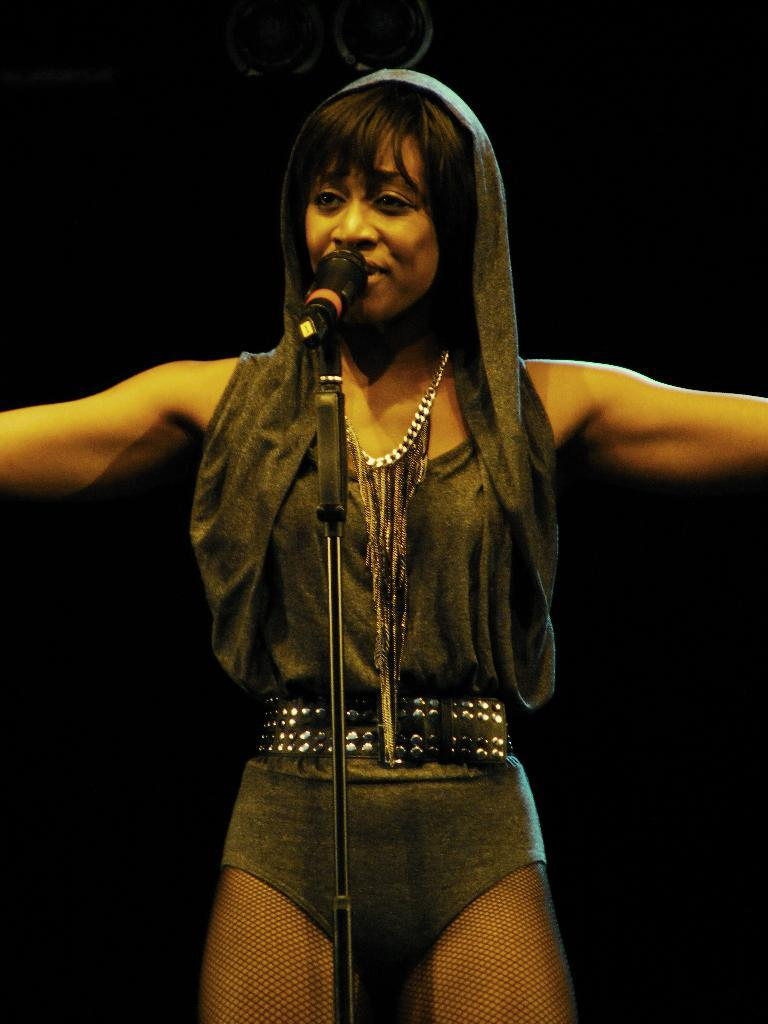Who is the main subject in the foreground of the image? There is a woman in the foreground of the image. What is the woman doing in front of the mic? The woman is standing in front of a mic. What is the woman's body language in the image? The woman is stretching both her hands. What is the color of the background in the image? The background of the image is dark. What type of sink is visible in the image? There is no sink present in the image. What musical instrument is the woman playing in the image? The woman is not playing any musical instrument in the image; she is standing in front of a mic with her hands stretched. 